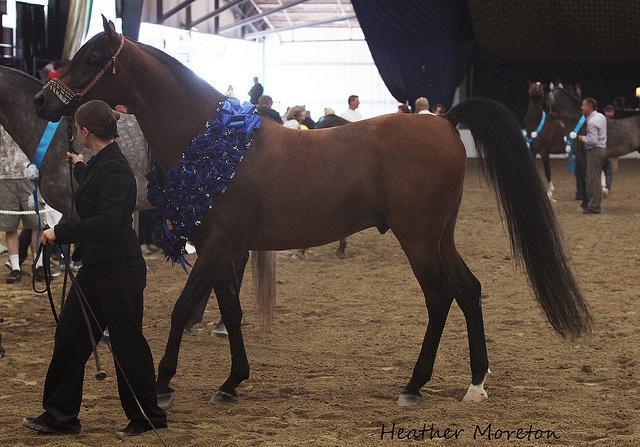How many saddles do you see?
Give a very brief answer. 0. How many spots are on the horse with the blue harness?
Give a very brief answer. 0. How many people are there?
Give a very brief answer. 3. How many horses are there?
Give a very brief answer. 3. 